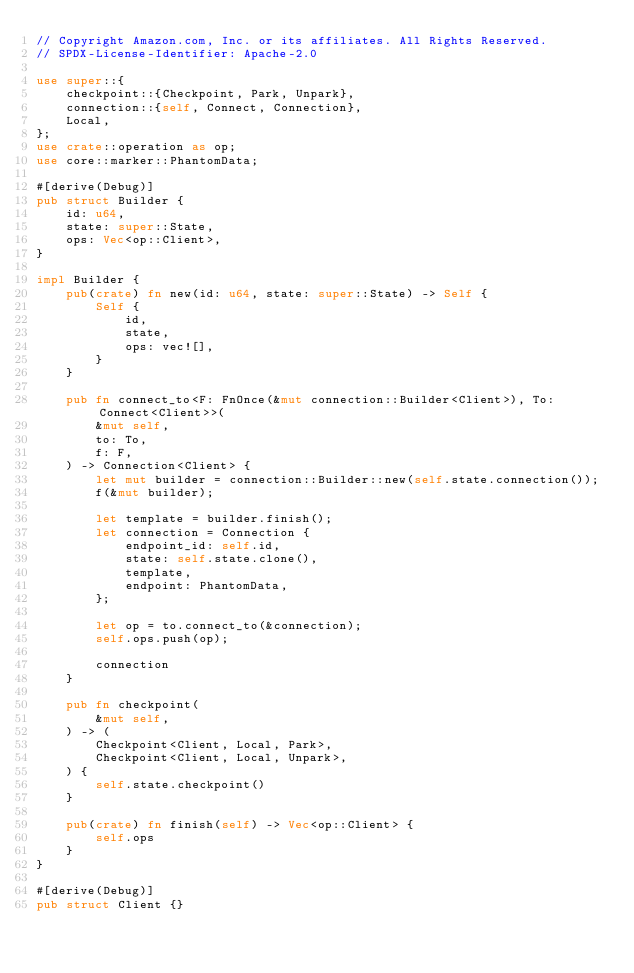Convert code to text. <code><loc_0><loc_0><loc_500><loc_500><_Rust_>// Copyright Amazon.com, Inc. or its affiliates. All Rights Reserved.
// SPDX-License-Identifier: Apache-2.0

use super::{
    checkpoint::{Checkpoint, Park, Unpark},
    connection::{self, Connect, Connection},
    Local,
};
use crate::operation as op;
use core::marker::PhantomData;

#[derive(Debug)]
pub struct Builder {
    id: u64,
    state: super::State,
    ops: Vec<op::Client>,
}

impl Builder {
    pub(crate) fn new(id: u64, state: super::State) -> Self {
        Self {
            id,
            state,
            ops: vec![],
        }
    }

    pub fn connect_to<F: FnOnce(&mut connection::Builder<Client>), To: Connect<Client>>(
        &mut self,
        to: To,
        f: F,
    ) -> Connection<Client> {
        let mut builder = connection::Builder::new(self.state.connection());
        f(&mut builder);

        let template = builder.finish();
        let connection = Connection {
            endpoint_id: self.id,
            state: self.state.clone(),
            template,
            endpoint: PhantomData,
        };

        let op = to.connect_to(&connection);
        self.ops.push(op);

        connection
    }

    pub fn checkpoint(
        &mut self,
    ) -> (
        Checkpoint<Client, Local, Park>,
        Checkpoint<Client, Local, Unpark>,
    ) {
        self.state.checkpoint()
    }

    pub(crate) fn finish(self) -> Vec<op::Client> {
        self.ops
    }
}

#[derive(Debug)]
pub struct Client {}
</code> 